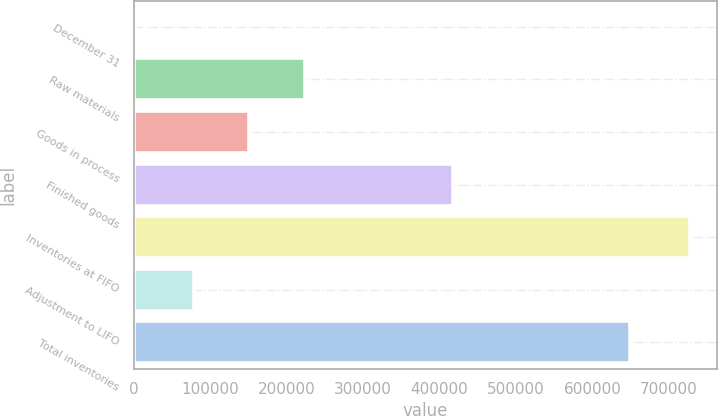<chart> <loc_0><loc_0><loc_500><loc_500><bar_chart><fcel>December 31<fcel>Raw materials<fcel>Goods in process<fcel>Finished goods<fcel>Inventories at FIFO<fcel>Adjustment to LIFO<fcel>Total inventories<nl><fcel>2006<fcel>223569<fcel>151037<fcel>418250<fcel>727325<fcel>78505<fcel>648820<nl></chart> 